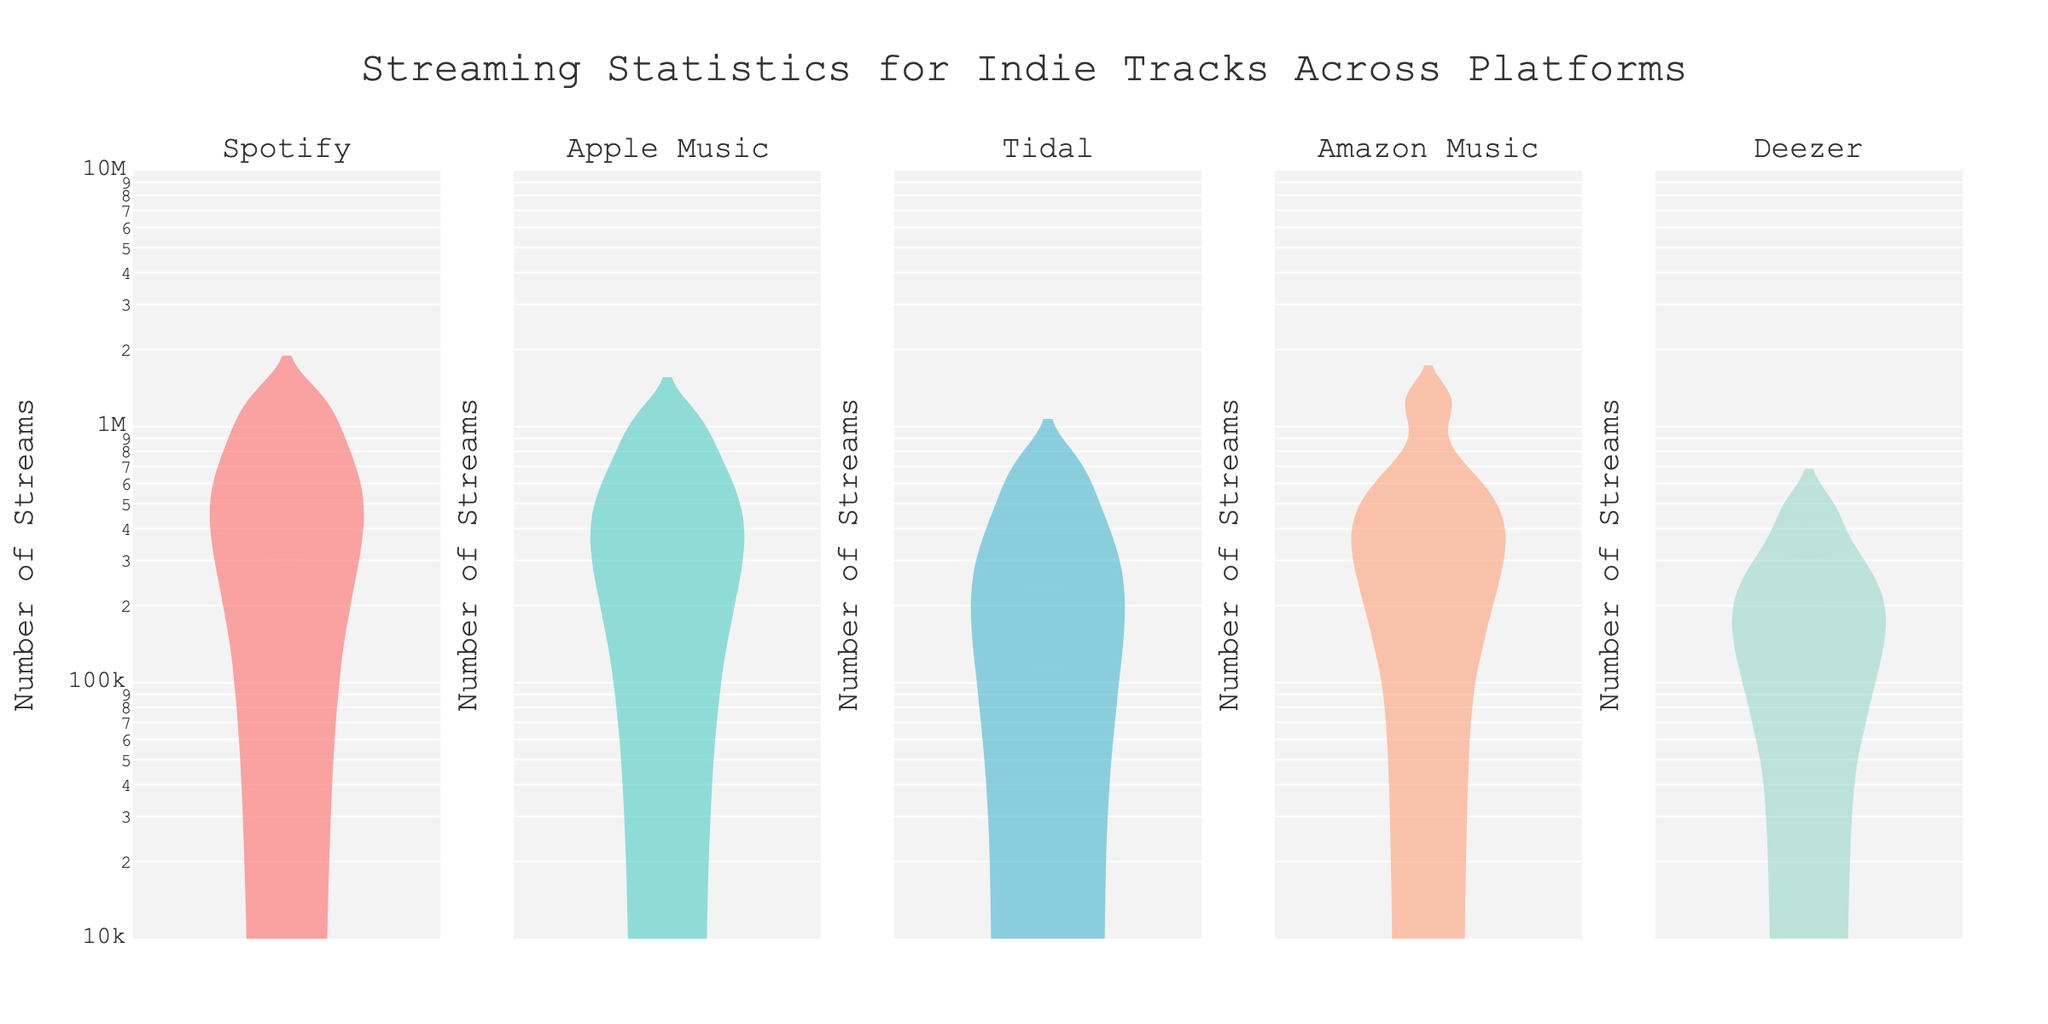What is the title of the plot? The title is usually placed at the top of the figure. In this plot, it reads "Streaming Statistics for Indie Tracks Across Platforms".
Answer: Streaming Statistics for Indie Tracks Across Platforms Which axis is shared among all subplots? The figure description mentions “shared_yaxes=True”, which means the y-axes are shared. Observation of the plot shows a unified y-axis denoting "Number of Streams".
Answer: y-axis What platform has tracks with the highest median stream count? By looking at the line in the center of each violin plot, which represents the median, Spotify has this line at a higher position compared to others.
Answer: Spotify How many platforms are represented in this plot? The subplot titles denote each platform. Observe all subplot titles to count the number of different platforms.
Answer: 5 Which platform shows the least variability in stream counts? Variability in a violin plot can be inferred by the spread of the distribution. Tidal shows the least spread in its distribution range.
Answer: Tidal Which track has the highest number of streams on Apple Music? Identify the distribution peaks for Apple Music, then the max value to find the track. "The Suburbs" by Arcade Fire peaks at the highest value.
Answer: The Suburbs by Arcade Fire Compare the mean stream counts between Amazon Music and Deezer platforms. Which has higher mean values? Mean lines in violin plots indicate the average. By comparing these lines, you observe that Amazon Music’s mean line is higher than Deezer’s.
Answer: Amazon Music Which platform has the largest range in number of streams? The range is the difference between the maximum and minimum points of each violin plot. Spotify's plot has the widest spread from smallest to largest values.
Answer: Spotify Are streams on Tidal generally higher or lower than those on Spotify? Compare the general spread and central tendency (median) of the violin plots for both platforms. Streams on Tidal are generally lower than Spotify.
Answer: Lower Is the track "Not Your Summer" streamed more on Spotify or Apple Music? Compare the positions of individual data points labeled "Not Your Summer" on both Spotify and Apple Music subplots. Spotify shows higher values.
Answer: Spotify 